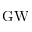Convert formula to latex. <formula><loc_0><loc_0><loc_500><loc_500>G W</formula> 